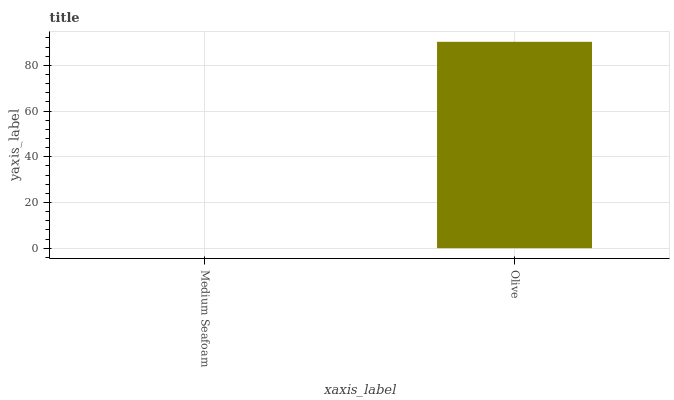Is Olive the minimum?
Answer yes or no. No. Is Olive greater than Medium Seafoam?
Answer yes or no. Yes. Is Medium Seafoam less than Olive?
Answer yes or no. Yes. Is Medium Seafoam greater than Olive?
Answer yes or no. No. Is Olive less than Medium Seafoam?
Answer yes or no. No. Is Olive the high median?
Answer yes or no. Yes. Is Medium Seafoam the low median?
Answer yes or no. Yes. Is Medium Seafoam the high median?
Answer yes or no. No. Is Olive the low median?
Answer yes or no. No. 